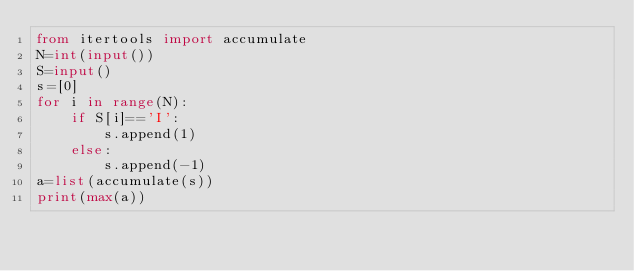<code> <loc_0><loc_0><loc_500><loc_500><_Python_>from itertools import accumulate
N=int(input())
S=input()
s=[0]
for i in range(N):
    if S[i]=='I':
        s.append(1)
    else:
        s.append(-1)
a=list(accumulate(s))
print(max(a))
</code> 